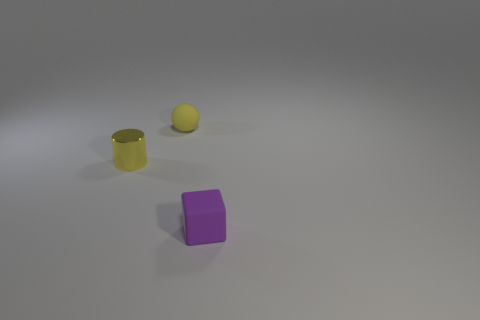Could you tell me the function of these objects? Without additional context, it's difficult to ascertain their exact functions. The shapes suggest that they could be children's toys used for educational purposes, such as teaching shapes and colors. Alternatively, they might be simply decorative or representative models for display. 